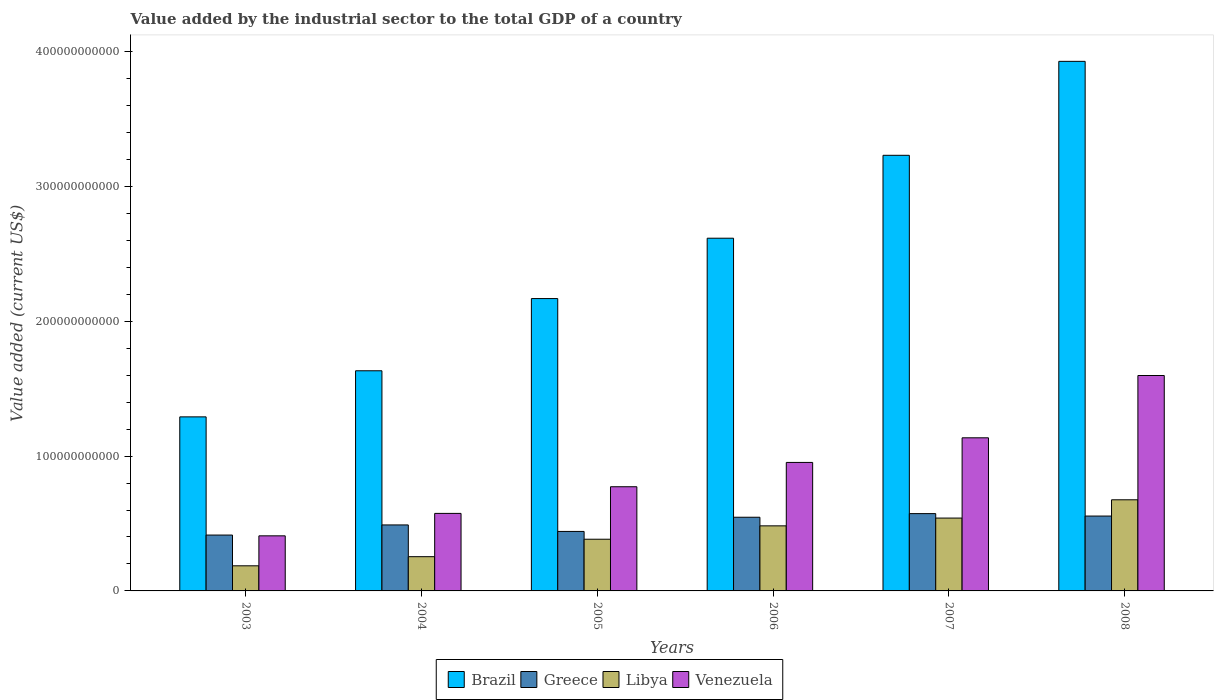How many different coloured bars are there?
Provide a succinct answer. 4. Are the number of bars per tick equal to the number of legend labels?
Offer a very short reply. Yes. Are the number of bars on each tick of the X-axis equal?
Ensure brevity in your answer.  Yes. How many bars are there on the 3rd tick from the left?
Make the answer very short. 4. How many bars are there on the 4th tick from the right?
Your answer should be compact. 4. What is the label of the 6th group of bars from the left?
Your response must be concise. 2008. In how many cases, is the number of bars for a given year not equal to the number of legend labels?
Provide a short and direct response. 0. What is the value added by the industrial sector to the total GDP in Libya in 2007?
Offer a terse response. 5.40e+1. Across all years, what is the maximum value added by the industrial sector to the total GDP in Venezuela?
Provide a short and direct response. 1.60e+11. Across all years, what is the minimum value added by the industrial sector to the total GDP in Libya?
Your response must be concise. 1.86e+1. What is the total value added by the industrial sector to the total GDP in Greece in the graph?
Keep it short and to the point. 3.02e+11. What is the difference between the value added by the industrial sector to the total GDP in Venezuela in 2004 and that in 2005?
Keep it short and to the point. -1.98e+1. What is the difference between the value added by the industrial sector to the total GDP in Brazil in 2005 and the value added by the industrial sector to the total GDP in Libya in 2004?
Keep it short and to the point. 1.91e+11. What is the average value added by the industrial sector to the total GDP in Libya per year?
Keep it short and to the point. 4.20e+1. In the year 2003, what is the difference between the value added by the industrial sector to the total GDP in Greece and value added by the industrial sector to the total GDP in Libya?
Your response must be concise. 2.28e+1. In how many years, is the value added by the industrial sector to the total GDP in Greece greater than 160000000000 US$?
Your answer should be compact. 0. What is the ratio of the value added by the industrial sector to the total GDP in Venezuela in 2003 to that in 2006?
Provide a succinct answer. 0.43. Is the difference between the value added by the industrial sector to the total GDP in Greece in 2003 and 2008 greater than the difference between the value added by the industrial sector to the total GDP in Libya in 2003 and 2008?
Your response must be concise. Yes. What is the difference between the highest and the second highest value added by the industrial sector to the total GDP in Libya?
Give a very brief answer. 1.35e+1. What is the difference between the highest and the lowest value added by the industrial sector to the total GDP in Brazil?
Your response must be concise. 2.64e+11. Is it the case that in every year, the sum of the value added by the industrial sector to the total GDP in Libya and value added by the industrial sector to the total GDP in Venezuela is greater than the sum of value added by the industrial sector to the total GDP in Greece and value added by the industrial sector to the total GDP in Brazil?
Your answer should be very brief. No. What does the 4th bar from the left in 2005 represents?
Provide a short and direct response. Venezuela. What does the 4th bar from the right in 2006 represents?
Your answer should be very brief. Brazil. Is it the case that in every year, the sum of the value added by the industrial sector to the total GDP in Libya and value added by the industrial sector to the total GDP in Greece is greater than the value added by the industrial sector to the total GDP in Brazil?
Offer a terse response. No. How many bars are there?
Provide a short and direct response. 24. Are all the bars in the graph horizontal?
Your answer should be very brief. No. What is the difference between two consecutive major ticks on the Y-axis?
Offer a terse response. 1.00e+11. Are the values on the major ticks of Y-axis written in scientific E-notation?
Keep it short and to the point. No. Does the graph contain any zero values?
Provide a short and direct response. No. Where does the legend appear in the graph?
Offer a terse response. Bottom center. What is the title of the graph?
Offer a very short reply. Value added by the industrial sector to the total GDP of a country. Does "Solomon Islands" appear as one of the legend labels in the graph?
Provide a succinct answer. No. What is the label or title of the X-axis?
Keep it short and to the point. Years. What is the label or title of the Y-axis?
Give a very brief answer. Value added (current US$). What is the Value added (current US$) of Brazil in 2003?
Give a very brief answer. 1.29e+11. What is the Value added (current US$) in Greece in 2003?
Provide a short and direct response. 4.14e+1. What is the Value added (current US$) of Libya in 2003?
Give a very brief answer. 1.86e+1. What is the Value added (current US$) of Venezuela in 2003?
Offer a terse response. 4.08e+1. What is the Value added (current US$) in Brazil in 2004?
Your answer should be compact. 1.63e+11. What is the Value added (current US$) in Greece in 2004?
Provide a short and direct response. 4.89e+1. What is the Value added (current US$) of Libya in 2004?
Offer a very short reply. 2.54e+1. What is the Value added (current US$) in Venezuela in 2004?
Give a very brief answer. 5.75e+1. What is the Value added (current US$) of Brazil in 2005?
Offer a terse response. 2.17e+11. What is the Value added (current US$) in Greece in 2005?
Your response must be concise. 4.41e+1. What is the Value added (current US$) in Libya in 2005?
Provide a short and direct response. 3.83e+1. What is the Value added (current US$) of Venezuela in 2005?
Provide a short and direct response. 7.73e+1. What is the Value added (current US$) in Brazil in 2006?
Your response must be concise. 2.62e+11. What is the Value added (current US$) of Greece in 2006?
Provide a succinct answer. 5.46e+1. What is the Value added (current US$) of Libya in 2006?
Keep it short and to the point. 4.83e+1. What is the Value added (current US$) of Venezuela in 2006?
Make the answer very short. 9.53e+1. What is the Value added (current US$) in Brazil in 2007?
Provide a succinct answer. 3.23e+11. What is the Value added (current US$) in Greece in 2007?
Your response must be concise. 5.73e+1. What is the Value added (current US$) in Libya in 2007?
Offer a terse response. 5.40e+1. What is the Value added (current US$) of Venezuela in 2007?
Give a very brief answer. 1.14e+11. What is the Value added (current US$) in Brazil in 2008?
Keep it short and to the point. 3.93e+11. What is the Value added (current US$) of Greece in 2008?
Your answer should be very brief. 5.55e+1. What is the Value added (current US$) of Libya in 2008?
Provide a short and direct response. 6.76e+1. What is the Value added (current US$) of Venezuela in 2008?
Your answer should be very brief. 1.60e+11. Across all years, what is the maximum Value added (current US$) of Brazil?
Your response must be concise. 3.93e+11. Across all years, what is the maximum Value added (current US$) in Greece?
Make the answer very short. 5.73e+1. Across all years, what is the maximum Value added (current US$) of Libya?
Your answer should be compact. 6.76e+1. Across all years, what is the maximum Value added (current US$) of Venezuela?
Make the answer very short. 1.60e+11. Across all years, what is the minimum Value added (current US$) of Brazil?
Provide a short and direct response. 1.29e+11. Across all years, what is the minimum Value added (current US$) in Greece?
Provide a succinct answer. 4.14e+1. Across all years, what is the minimum Value added (current US$) in Libya?
Your response must be concise. 1.86e+1. Across all years, what is the minimum Value added (current US$) of Venezuela?
Make the answer very short. 4.08e+1. What is the total Value added (current US$) in Brazil in the graph?
Your answer should be compact. 1.49e+12. What is the total Value added (current US$) of Greece in the graph?
Ensure brevity in your answer.  3.02e+11. What is the total Value added (current US$) in Libya in the graph?
Offer a very short reply. 2.52e+11. What is the total Value added (current US$) in Venezuela in the graph?
Offer a terse response. 5.44e+11. What is the difference between the Value added (current US$) of Brazil in 2003 and that in 2004?
Your answer should be compact. -3.42e+1. What is the difference between the Value added (current US$) in Greece in 2003 and that in 2004?
Offer a very short reply. -7.50e+09. What is the difference between the Value added (current US$) in Libya in 2003 and that in 2004?
Offer a very short reply. -6.77e+09. What is the difference between the Value added (current US$) of Venezuela in 2003 and that in 2004?
Make the answer very short. -1.66e+1. What is the difference between the Value added (current US$) in Brazil in 2003 and that in 2005?
Provide a short and direct response. -8.77e+1. What is the difference between the Value added (current US$) in Greece in 2003 and that in 2005?
Offer a terse response. -2.69e+09. What is the difference between the Value added (current US$) in Libya in 2003 and that in 2005?
Make the answer very short. -1.97e+1. What is the difference between the Value added (current US$) of Venezuela in 2003 and that in 2005?
Offer a terse response. -3.64e+1. What is the difference between the Value added (current US$) of Brazil in 2003 and that in 2006?
Provide a short and direct response. -1.32e+11. What is the difference between the Value added (current US$) in Greece in 2003 and that in 2006?
Ensure brevity in your answer.  -1.32e+1. What is the difference between the Value added (current US$) in Libya in 2003 and that in 2006?
Provide a succinct answer. -2.96e+1. What is the difference between the Value added (current US$) in Venezuela in 2003 and that in 2006?
Offer a very short reply. -5.44e+1. What is the difference between the Value added (current US$) of Brazil in 2003 and that in 2007?
Provide a succinct answer. -1.94e+11. What is the difference between the Value added (current US$) in Greece in 2003 and that in 2007?
Make the answer very short. -1.59e+1. What is the difference between the Value added (current US$) in Libya in 2003 and that in 2007?
Give a very brief answer. -3.54e+1. What is the difference between the Value added (current US$) of Venezuela in 2003 and that in 2007?
Your answer should be very brief. -7.27e+1. What is the difference between the Value added (current US$) in Brazil in 2003 and that in 2008?
Give a very brief answer. -2.64e+11. What is the difference between the Value added (current US$) in Greece in 2003 and that in 2008?
Ensure brevity in your answer.  -1.41e+1. What is the difference between the Value added (current US$) of Libya in 2003 and that in 2008?
Offer a terse response. -4.89e+1. What is the difference between the Value added (current US$) of Venezuela in 2003 and that in 2008?
Keep it short and to the point. -1.19e+11. What is the difference between the Value added (current US$) in Brazil in 2004 and that in 2005?
Provide a succinct answer. -5.35e+1. What is the difference between the Value added (current US$) of Greece in 2004 and that in 2005?
Provide a short and direct response. 4.82e+09. What is the difference between the Value added (current US$) of Libya in 2004 and that in 2005?
Your answer should be very brief. -1.29e+1. What is the difference between the Value added (current US$) of Venezuela in 2004 and that in 2005?
Your answer should be compact. -1.98e+1. What is the difference between the Value added (current US$) of Brazil in 2004 and that in 2006?
Offer a terse response. -9.83e+1. What is the difference between the Value added (current US$) of Greece in 2004 and that in 2006?
Your answer should be very brief. -5.70e+09. What is the difference between the Value added (current US$) in Libya in 2004 and that in 2006?
Give a very brief answer. -2.29e+1. What is the difference between the Value added (current US$) in Venezuela in 2004 and that in 2006?
Offer a very short reply. -3.78e+1. What is the difference between the Value added (current US$) of Brazil in 2004 and that in 2007?
Provide a short and direct response. -1.60e+11. What is the difference between the Value added (current US$) in Greece in 2004 and that in 2007?
Keep it short and to the point. -8.39e+09. What is the difference between the Value added (current US$) of Libya in 2004 and that in 2007?
Your answer should be compact. -2.86e+1. What is the difference between the Value added (current US$) of Venezuela in 2004 and that in 2007?
Provide a succinct answer. -5.61e+1. What is the difference between the Value added (current US$) in Brazil in 2004 and that in 2008?
Give a very brief answer. -2.29e+11. What is the difference between the Value added (current US$) of Greece in 2004 and that in 2008?
Your answer should be compact. -6.58e+09. What is the difference between the Value added (current US$) in Libya in 2004 and that in 2008?
Offer a very short reply. -4.22e+1. What is the difference between the Value added (current US$) of Venezuela in 2004 and that in 2008?
Offer a terse response. -1.02e+11. What is the difference between the Value added (current US$) in Brazil in 2005 and that in 2006?
Make the answer very short. -4.48e+1. What is the difference between the Value added (current US$) in Greece in 2005 and that in 2006?
Offer a very short reply. -1.05e+1. What is the difference between the Value added (current US$) of Libya in 2005 and that in 2006?
Keep it short and to the point. -9.93e+09. What is the difference between the Value added (current US$) in Venezuela in 2005 and that in 2006?
Ensure brevity in your answer.  -1.80e+1. What is the difference between the Value added (current US$) in Brazil in 2005 and that in 2007?
Give a very brief answer. -1.06e+11. What is the difference between the Value added (current US$) in Greece in 2005 and that in 2007?
Your answer should be very brief. -1.32e+1. What is the difference between the Value added (current US$) in Libya in 2005 and that in 2007?
Your answer should be very brief. -1.57e+1. What is the difference between the Value added (current US$) in Venezuela in 2005 and that in 2007?
Your answer should be compact. -3.63e+1. What is the difference between the Value added (current US$) in Brazil in 2005 and that in 2008?
Your response must be concise. -1.76e+11. What is the difference between the Value added (current US$) in Greece in 2005 and that in 2008?
Make the answer very short. -1.14e+1. What is the difference between the Value added (current US$) of Libya in 2005 and that in 2008?
Give a very brief answer. -2.92e+1. What is the difference between the Value added (current US$) in Venezuela in 2005 and that in 2008?
Make the answer very short. -8.25e+1. What is the difference between the Value added (current US$) in Brazil in 2006 and that in 2007?
Your answer should be compact. -6.15e+1. What is the difference between the Value added (current US$) in Greece in 2006 and that in 2007?
Give a very brief answer. -2.70e+09. What is the difference between the Value added (current US$) of Libya in 2006 and that in 2007?
Offer a terse response. -5.77e+09. What is the difference between the Value added (current US$) in Venezuela in 2006 and that in 2007?
Ensure brevity in your answer.  -1.83e+1. What is the difference between the Value added (current US$) in Brazil in 2006 and that in 2008?
Keep it short and to the point. -1.31e+11. What is the difference between the Value added (current US$) in Greece in 2006 and that in 2008?
Your response must be concise. -8.79e+08. What is the difference between the Value added (current US$) in Libya in 2006 and that in 2008?
Provide a short and direct response. -1.93e+1. What is the difference between the Value added (current US$) in Venezuela in 2006 and that in 2008?
Offer a very short reply. -6.45e+1. What is the difference between the Value added (current US$) of Brazil in 2007 and that in 2008?
Offer a terse response. -6.97e+1. What is the difference between the Value added (current US$) of Greece in 2007 and that in 2008?
Ensure brevity in your answer.  1.82e+09. What is the difference between the Value added (current US$) of Libya in 2007 and that in 2008?
Make the answer very short. -1.35e+1. What is the difference between the Value added (current US$) of Venezuela in 2007 and that in 2008?
Make the answer very short. -4.62e+1. What is the difference between the Value added (current US$) in Brazil in 2003 and the Value added (current US$) in Greece in 2004?
Provide a short and direct response. 8.01e+1. What is the difference between the Value added (current US$) in Brazil in 2003 and the Value added (current US$) in Libya in 2004?
Make the answer very short. 1.04e+11. What is the difference between the Value added (current US$) of Brazil in 2003 and the Value added (current US$) of Venezuela in 2004?
Offer a terse response. 7.16e+1. What is the difference between the Value added (current US$) of Greece in 2003 and the Value added (current US$) of Libya in 2004?
Your response must be concise. 1.60e+1. What is the difference between the Value added (current US$) of Greece in 2003 and the Value added (current US$) of Venezuela in 2004?
Give a very brief answer. -1.60e+1. What is the difference between the Value added (current US$) in Libya in 2003 and the Value added (current US$) in Venezuela in 2004?
Offer a terse response. -3.89e+1. What is the difference between the Value added (current US$) in Brazil in 2003 and the Value added (current US$) in Greece in 2005?
Make the answer very short. 8.49e+1. What is the difference between the Value added (current US$) of Brazil in 2003 and the Value added (current US$) of Libya in 2005?
Offer a very short reply. 9.07e+1. What is the difference between the Value added (current US$) of Brazil in 2003 and the Value added (current US$) of Venezuela in 2005?
Your answer should be very brief. 5.18e+1. What is the difference between the Value added (current US$) of Greece in 2003 and the Value added (current US$) of Libya in 2005?
Keep it short and to the point. 3.10e+09. What is the difference between the Value added (current US$) in Greece in 2003 and the Value added (current US$) in Venezuela in 2005?
Your answer should be very brief. -3.58e+1. What is the difference between the Value added (current US$) of Libya in 2003 and the Value added (current US$) of Venezuela in 2005?
Your answer should be compact. -5.86e+1. What is the difference between the Value added (current US$) in Brazil in 2003 and the Value added (current US$) in Greece in 2006?
Your answer should be compact. 7.44e+1. What is the difference between the Value added (current US$) of Brazil in 2003 and the Value added (current US$) of Libya in 2006?
Make the answer very short. 8.08e+1. What is the difference between the Value added (current US$) in Brazil in 2003 and the Value added (current US$) in Venezuela in 2006?
Provide a short and direct response. 3.38e+1. What is the difference between the Value added (current US$) in Greece in 2003 and the Value added (current US$) in Libya in 2006?
Offer a terse response. -6.83e+09. What is the difference between the Value added (current US$) of Greece in 2003 and the Value added (current US$) of Venezuela in 2006?
Provide a succinct answer. -5.38e+1. What is the difference between the Value added (current US$) of Libya in 2003 and the Value added (current US$) of Venezuela in 2006?
Give a very brief answer. -7.67e+1. What is the difference between the Value added (current US$) in Brazil in 2003 and the Value added (current US$) in Greece in 2007?
Provide a succinct answer. 7.17e+1. What is the difference between the Value added (current US$) of Brazil in 2003 and the Value added (current US$) of Libya in 2007?
Provide a short and direct response. 7.50e+1. What is the difference between the Value added (current US$) in Brazil in 2003 and the Value added (current US$) in Venezuela in 2007?
Make the answer very short. 1.55e+1. What is the difference between the Value added (current US$) of Greece in 2003 and the Value added (current US$) of Libya in 2007?
Provide a short and direct response. -1.26e+1. What is the difference between the Value added (current US$) in Greece in 2003 and the Value added (current US$) in Venezuela in 2007?
Ensure brevity in your answer.  -7.21e+1. What is the difference between the Value added (current US$) of Libya in 2003 and the Value added (current US$) of Venezuela in 2007?
Your answer should be very brief. -9.49e+1. What is the difference between the Value added (current US$) in Brazil in 2003 and the Value added (current US$) in Greece in 2008?
Offer a very short reply. 7.35e+1. What is the difference between the Value added (current US$) of Brazil in 2003 and the Value added (current US$) of Libya in 2008?
Offer a terse response. 6.15e+1. What is the difference between the Value added (current US$) of Brazil in 2003 and the Value added (current US$) of Venezuela in 2008?
Offer a very short reply. -3.07e+1. What is the difference between the Value added (current US$) in Greece in 2003 and the Value added (current US$) in Libya in 2008?
Provide a succinct answer. -2.61e+1. What is the difference between the Value added (current US$) in Greece in 2003 and the Value added (current US$) in Venezuela in 2008?
Your answer should be compact. -1.18e+11. What is the difference between the Value added (current US$) of Libya in 2003 and the Value added (current US$) of Venezuela in 2008?
Ensure brevity in your answer.  -1.41e+11. What is the difference between the Value added (current US$) in Brazil in 2004 and the Value added (current US$) in Greece in 2005?
Provide a short and direct response. 1.19e+11. What is the difference between the Value added (current US$) in Brazil in 2004 and the Value added (current US$) in Libya in 2005?
Your answer should be compact. 1.25e+11. What is the difference between the Value added (current US$) of Brazil in 2004 and the Value added (current US$) of Venezuela in 2005?
Your answer should be very brief. 8.60e+1. What is the difference between the Value added (current US$) of Greece in 2004 and the Value added (current US$) of Libya in 2005?
Make the answer very short. 1.06e+1. What is the difference between the Value added (current US$) of Greece in 2004 and the Value added (current US$) of Venezuela in 2005?
Keep it short and to the point. -2.83e+1. What is the difference between the Value added (current US$) in Libya in 2004 and the Value added (current US$) in Venezuela in 2005?
Ensure brevity in your answer.  -5.19e+1. What is the difference between the Value added (current US$) in Brazil in 2004 and the Value added (current US$) in Greece in 2006?
Provide a short and direct response. 1.09e+11. What is the difference between the Value added (current US$) of Brazil in 2004 and the Value added (current US$) of Libya in 2006?
Ensure brevity in your answer.  1.15e+11. What is the difference between the Value added (current US$) in Brazil in 2004 and the Value added (current US$) in Venezuela in 2006?
Offer a very short reply. 6.80e+1. What is the difference between the Value added (current US$) of Greece in 2004 and the Value added (current US$) of Libya in 2006?
Your answer should be compact. 6.77e+08. What is the difference between the Value added (current US$) in Greece in 2004 and the Value added (current US$) in Venezuela in 2006?
Provide a short and direct response. -4.63e+1. What is the difference between the Value added (current US$) of Libya in 2004 and the Value added (current US$) of Venezuela in 2006?
Offer a very short reply. -6.99e+1. What is the difference between the Value added (current US$) of Brazil in 2004 and the Value added (current US$) of Greece in 2007?
Give a very brief answer. 1.06e+11. What is the difference between the Value added (current US$) of Brazil in 2004 and the Value added (current US$) of Libya in 2007?
Make the answer very short. 1.09e+11. What is the difference between the Value added (current US$) of Brazil in 2004 and the Value added (current US$) of Venezuela in 2007?
Provide a succinct answer. 4.97e+1. What is the difference between the Value added (current US$) in Greece in 2004 and the Value added (current US$) in Libya in 2007?
Your answer should be compact. -5.09e+09. What is the difference between the Value added (current US$) of Greece in 2004 and the Value added (current US$) of Venezuela in 2007?
Provide a short and direct response. -6.46e+1. What is the difference between the Value added (current US$) in Libya in 2004 and the Value added (current US$) in Venezuela in 2007?
Your answer should be compact. -8.81e+1. What is the difference between the Value added (current US$) in Brazil in 2004 and the Value added (current US$) in Greece in 2008?
Offer a terse response. 1.08e+11. What is the difference between the Value added (current US$) in Brazil in 2004 and the Value added (current US$) in Libya in 2008?
Give a very brief answer. 9.57e+1. What is the difference between the Value added (current US$) in Brazil in 2004 and the Value added (current US$) in Venezuela in 2008?
Make the answer very short. 3.50e+09. What is the difference between the Value added (current US$) in Greece in 2004 and the Value added (current US$) in Libya in 2008?
Provide a short and direct response. -1.86e+1. What is the difference between the Value added (current US$) in Greece in 2004 and the Value added (current US$) in Venezuela in 2008?
Provide a succinct answer. -1.11e+11. What is the difference between the Value added (current US$) of Libya in 2004 and the Value added (current US$) of Venezuela in 2008?
Provide a succinct answer. -1.34e+11. What is the difference between the Value added (current US$) of Brazil in 2005 and the Value added (current US$) of Greece in 2006?
Your answer should be very brief. 1.62e+11. What is the difference between the Value added (current US$) in Brazil in 2005 and the Value added (current US$) in Libya in 2006?
Provide a short and direct response. 1.69e+11. What is the difference between the Value added (current US$) of Brazil in 2005 and the Value added (current US$) of Venezuela in 2006?
Keep it short and to the point. 1.22e+11. What is the difference between the Value added (current US$) in Greece in 2005 and the Value added (current US$) in Libya in 2006?
Offer a terse response. -4.14e+09. What is the difference between the Value added (current US$) in Greece in 2005 and the Value added (current US$) in Venezuela in 2006?
Your response must be concise. -5.12e+1. What is the difference between the Value added (current US$) in Libya in 2005 and the Value added (current US$) in Venezuela in 2006?
Provide a succinct answer. -5.69e+1. What is the difference between the Value added (current US$) in Brazil in 2005 and the Value added (current US$) in Greece in 2007?
Keep it short and to the point. 1.59e+11. What is the difference between the Value added (current US$) of Brazil in 2005 and the Value added (current US$) of Libya in 2007?
Your answer should be compact. 1.63e+11. What is the difference between the Value added (current US$) in Brazil in 2005 and the Value added (current US$) in Venezuela in 2007?
Give a very brief answer. 1.03e+11. What is the difference between the Value added (current US$) in Greece in 2005 and the Value added (current US$) in Libya in 2007?
Ensure brevity in your answer.  -9.91e+09. What is the difference between the Value added (current US$) of Greece in 2005 and the Value added (current US$) of Venezuela in 2007?
Offer a very short reply. -6.94e+1. What is the difference between the Value added (current US$) in Libya in 2005 and the Value added (current US$) in Venezuela in 2007?
Offer a very short reply. -7.52e+1. What is the difference between the Value added (current US$) in Brazil in 2005 and the Value added (current US$) in Greece in 2008?
Your answer should be compact. 1.61e+11. What is the difference between the Value added (current US$) of Brazil in 2005 and the Value added (current US$) of Libya in 2008?
Ensure brevity in your answer.  1.49e+11. What is the difference between the Value added (current US$) in Brazil in 2005 and the Value added (current US$) in Venezuela in 2008?
Make the answer very short. 5.70e+1. What is the difference between the Value added (current US$) of Greece in 2005 and the Value added (current US$) of Libya in 2008?
Keep it short and to the point. -2.35e+1. What is the difference between the Value added (current US$) of Greece in 2005 and the Value added (current US$) of Venezuela in 2008?
Give a very brief answer. -1.16e+11. What is the difference between the Value added (current US$) of Libya in 2005 and the Value added (current US$) of Venezuela in 2008?
Ensure brevity in your answer.  -1.21e+11. What is the difference between the Value added (current US$) in Brazil in 2006 and the Value added (current US$) in Greece in 2007?
Provide a succinct answer. 2.04e+11. What is the difference between the Value added (current US$) in Brazil in 2006 and the Value added (current US$) in Libya in 2007?
Make the answer very short. 2.08e+11. What is the difference between the Value added (current US$) in Brazil in 2006 and the Value added (current US$) in Venezuela in 2007?
Provide a short and direct response. 1.48e+11. What is the difference between the Value added (current US$) of Greece in 2006 and the Value added (current US$) of Libya in 2007?
Ensure brevity in your answer.  6.04e+08. What is the difference between the Value added (current US$) of Greece in 2006 and the Value added (current US$) of Venezuela in 2007?
Your answer should be compact. -5.89e+1. What is the difference between the Value added (current US$) of Libya in 2006 and the Value added (current US$) of Venezuela in 2007?
Keep it short and to the point. -6.53e+1. What is the difference between the Value added (current US$) in Brazil in 2006 and the Value added (current US$) in Greece in 2008?
Ensure brevity in your answer.  2.06e+11. What is the difference between the Value added (current US$) in Brazil in 2006 and the Value added (current US$) in Libya in 2008?
Your answer should be very brief. 1.94e+11. What is the difference between the Value added (current US$) of Brazil in 2006 and the Value added (current US$) of Venezuela in 2008?
Your answer should be very brief. 1.02e+11. What is the difference between the Value added (current US$) of Greece in 2006 and the Value added (current US$) of Libya in 2008?
Your answer should be compact. -1.29e+1. What is the difference between the Value added (current US$) in Greece in 2006 and the Value added (current US$) in Venezuela in 2008?
Offer a very short reply. -1.05e+11. What is the difference between the Value added (current US$) in Libya in 2006 and the Value added (current US$) in Venezuela in 2008?
Provide a succinct answer. -1.11e+11. What is the difference between the Value added (current US$) of Brazil in 2007 and the Value added (current US$) of Greece in 2008?
Your response must be concise. 2.68e+11. What is the difference between the Value added (current US$) of Brazil in 2007 and the Value added (current US$) of Libya in 2008?
Ensure brevity in your answer.  2.55e+11. What is the difference between the Value added (current US$) of Brazil in 2007 and the Value added (current US$) of Venezuela in 2008?
Offer a very short reply. 1.63e+11. What is the difference between the Value added (current US$) of Greece in 2007 and the Value added (current US$) of Libya in 2008?
Keep it short and to the point. -1.02e+1. What is the difference between the Value added (current US$) in Greece in 2007 and the Value added (current US$) in Venezuela in 2008?
Provide a succinct answer. -1.02e+11. What is the difference between the Value added (current US$) of Libya in 2007 and the Value added (current US$) of Venezuela in 2008?
Keep it short and to the point. -1.06e+11. What is the average Value added (current US$) in Brazil per year?
Your response must be concise. 2.48e+11. What is the average Value added (current US$) of Greece per year?
Make the answer very short. 5.03e+1. What is the average Value added (current US$) in Libya per year?
Provide a short and direct response. 4.20e+1. What is the average Value added (current US$) of Venezuela per year?
Ensure brevity in your answer.  9.07e+1. In the year 2003, what is the difference between the Value added (current US$) in Brazil and Value added (current US$) in Greece?
Offer a very short reply. 8.76e+1. In the year 2003, what is the difference between the Value added (current US$) in Brazil and Value added (current US$) in Libya?
Keep it short and to the point. 1.10e+11. In the year 2003, what is the difference between the Value added (current US$) of Brazil and Value added (current US$) of Venezuela?
Your response must be concise. 8.82e+1. In the year 2003, what is the difference between the Value added (current US$) of Greece and Value added (current US$) of Libya?
Ensure brevity in your answer.  2.28e+1. In the year 2003, what is the difference between the Value added (current US$) in Greece and Value added (current US$) in Venezuela?
Offer a terse response. 5.87e+08. In the year 2003, what is the difference between the Value added (current US$) of Libya and Value added (current US$) of Venezuela?
Give a very brief answer. -2.22e+1. In the year 2004, what is the difference between the Value added (current US$) in Brazil and Value added (current US$) in Greece?
Ensure brevity in your answer.  1.14e+11. In the year 2004, what is the difference between the Value added (current US$) of Brazil and Value added (current US$) of Libya?
Keep it short and to the point. 1.38e+11. In the year 2004, what is the difference between the Value added (current US$) in Brazil and Value added (current US$) in Venezuela?
Give a very brief answer. 1.06e+11. In the year 2004, what is the difference between the Value added (current US$) of Greece and Value added (current US$) of Libya?
Make the answer very short. 2.35e+1. In the year 2004, what is the difference between the Value added (current US$) of Greece and Value added (current US$) of Venezuela?
Offer a terse response. -8.55e+09. In the year 2004, what is the difference between the Value added (current US$) of Libya and Value added (current US$) of Venezuela?
Your answer should be very brief. -3.21e+1. In the year 2005, what is the difference between the Value added (current US$) of Brazil and Value added (current US$) of Greece?
Provide a short and direct response. 1.73e+11. In the year 2005, what is the difference between the Value added (current US$) of Brazil and Value added (current US$) of Libya?
Offer a very short reply. 1.78e+11. In the year 2005, what is the difference between the Value added (current US$) of Brazil and Value added (current US$) of Venezuela?
Your answer should be compact. 1.40e+11. In the year 2005, what is the difference between the Value added (current US$) in Greece and Value added (current US$) in Libya?
Provide a short and direct response. 5.79e+09. In the year 2005, what is the difference between the Value added (current US$) in Greece and Value added (current US$) in Venezuela?
Make the answer very short. -3.31e+1. In the year 2005, what is the difference between the Value added (current US$) in Libya and Value added (current US$) in Venezuela?
Provide a succinct answer. -3.89e+1. In the year 2006, what is the difference between the Value added (current US$) in Brazil and Value added (current US$) in Greece?
Provide a succinct answer. 2.07e+11. In the year 2006, what is the difference between the Value added (current US$) of Brazil and Value added (current US$) of Libya?
Your response must be concise. 2.13e+11. In the year 2006, what is the difference between the Value added (current US$) in Brazil and Value added (current US$) in Venezuela?
Offer a very short reply. 1.66e+11. In the year 2006, what is the difference between the Value added (current US$) of Greece and Value added (current US$) of Libya?
Your answer should be compact. 6.37e+09. In the year 2006, what is the difference between the Value added (current US$) in Greece and Value added (current US$) in Venezuela?
Your answer should be very brief. -4.06e+1. In the year 2006, what is the difference between the Value added (current US$) in Libya and Value added (current US$) in Venezuela?
Your answer should be compact. -4.70e+1. In the year 2007, what is the difference between the Value added (current US$) of Brazil and Value added (current US$) of Greece?
Ensure brevity in your answer.  2.66e+11. In the year 2007, what is the difference between the Value added (current US$) of Brazil and Value added (current US$) of Libya?
Your answer should be very brief. 2.69e+11. In the year 2007, what is the difference between the Value added (current US$) of Brazil and Value added (current US$) of Venezuela?
Your response must be concise. 2.09e+11. In the year 2007, what is the difference between the Value added (current US$) in Greece and Value added (current US$) in Libya?
Keep it short and to the point. 3.30e+09. In the year 2007, what is the difference between the Value added (current US$) in Greece and Value added (current US$) in Venezuela?
Ensure brevity in your answer.  -5.62e+1. In the year 2007, what is the difference between the Value added (current US$) in Libya and Value added (current US$) in Venezuela?
Provide a short and direct response. -5.95e+1. In the year 2008, what is the difference between the Value added (current US$) of Brazil and Value added (current US$) of Greece?
Your response must be concise. 3.37e+11. In the year 2008, what is the difference between the Value added (current US$) in Brazil and Value added (current US$) in Libya?
Provide a short and direct response. 3.25e+11. In the year 2008, what is the difference between the Value added (current US$) of Brazil and Value added (current US$) of Venezuela?
Ensure brevity in your answer.  2.33e+11. In the year 2008, what is the difference between the Value added (current US$) in Greece and Value added (current US$) in Libya?
Provide a short and direct response. -1.21e+1. In the year 2008, what is the difference between the Value added (current US$) of Greece and Value added (current US$) of Venezuela?
Offer a terse response. -1.04e+11. In the year 2008, what is the difference between the Value added (current US$) in Libya and Value added (current US$) in Venezuela?
Ensure brevity in your answer.  -9.22e+1. What is the ratio of the Value added (current US$) of Brazil in 2003 to that in 2004?
Give a very brief answer. 0.79. What is the ratio of the Value added (current US$) in Greece in 2003 to that in 2004?
Your response must be concise. 0.85. What is the ratio of the Value added (current US$) in Libya in 2003 to that in 2004?
Provide a short and direct response. 0.73. What is the ratio of the Value added (current US$) in Venezuela in 2003 to that in 2004?
Make the answer very short. 0.71. What is the ratio of the Value added (current US$) in Brazil in 2003 to that in 2005?
Keep it short and to the point. 0.6. What is the ratio of the Value added (current US$) of Greece in 2003 to that in 2005?
Offer a very short reply. 0.94. What is the ratio of the Value added (current US$) in Libya in 2003 to that in 2005?
Offer a very short reply. 0.49. What is the ratio of the Value added (current US$) in Venezuela in 2003 to that in 2005?
Offer a terse response. 0.53. What is the ratio of the Value added (current US$) in Brazil in 2003 to that in 2006?
Provide a short and direct response. 0.49. What is the ratio of the Value added (current US$) of Greece in 2003 to that in 2006?
Keep it short and to the point. 0.76. What is the ratio of the Value added (current US$) in Libya in 2003 to that in 2006?
Give a very brief answer. 0.39. What is the ratio of the Value added (current US$) of Venezuela in 2003 to that in 2006?
Your answer should be compact. 0.43. What is the ratio of the Value added (current US$) of Brazil in 2003 to that in 2007?
Give a very brief answer. 0.4. What is the ratio of the Value added (current US$) of Greece in 2003 to that in 2007?
Your answer should be very brief. 0.72. What is the ratio of the Value added (current US$) of Libya in 2003 to that in 2007?
Your response must be concise. 0.34. What is the ratio of the Value added (current US$) of Venezuela in 2003 to that in 2007?
Your answer should be compact. 0.36. What is the ratio of the Value added (current US$) in Brazil in 2003 to that in 2008?
Offer a very short reply. 0.33. What is the ratio of the Value added (current US$) of Greece in 2003 to that in 2008?
Keep it short and to the point. 0.75. What is the ratio of the Value added (current US$) in Libya in 2003 to that in 2008?
Keep it short and to the point. 0.28. What is the ratio of the Value added (current US$) in Venezuela in 2003 to that in 2008?
Offer a very short reply. 0.26. What is the ratio of the Value added (current US$) in Brazil in 2004 to that in 2005?
Keep it short and to the point. 0.75. What is the ratio of the Value added (current US$) in Greece in 2004 to that in 2005?
Your answer should be compact. 1.11. What is the ratio of the Value added (current US$) of Libya in 2004 to that in 2005?
Keep it short and to the point. 0.66. What is the ratio of the Value added (current US$) of Venezuela in 2004 to that in 2005?
Give a very brief answer. 0.74. What is the ratio of the Value added (current US$) of Brazil in 2004 to that in 2006?
Make the answer very short. 0.62. What is the ratio of the Value added (current US$) of Greece in 2004 to that in 2006?
Ensure brevity in your answer.  0.9. What is the ratio of the Value added (current US$) of Libya in 2004 to that in 2006?
Offer a very short reply. 0.53. What is the ratio of the Value added (current US$) of Venezuela in 2004 to that in 2006?
Your answer should be very brief. 0.6. What is the ratio of the Value added (current US$) of Brazil in 2004 to that in 2007?
Offer a terse response. 0.51. What is the ratio of the Value added (current US$) of Greece in 2004 to that in 2007?
Provide a short and direct response. 0.85. What is the ratio of the Value added (current US$) of Libya in 2004 to that in 2007?
Offer a terse response. 0.47. What is the ratio of the Value added (current US$) in Venezuela in 2004 to that in 2007?
Provide a succinct answer. 0.51. What is the ratio of the Value added (current US$) in Brazil in 2004 to that in 2008?
Your response must be concise. 0.42. What is the ratio of the Value added (current US$) of Greece in 2004 to that in 2008?
Provide a succinct answer. 0.88. What is the ratio of the Value added (current US$) in Libya in 2004 to that in 2008?
Provide a short and direct response. 0.38. What is the ratio of the Value added (current US$) in Venezuela in 2004 to that in 2008?
Keep it short and to the point. 0.36. What is the ratio of the Value added (current US$) of Brazil in 2005 to that in 2006?
Make the answer very short. 0.83. What is the ratio of the Value added (current US$) of Greece in 2005 to that in 2006?
Your response must be concise. 0.81. What is the ratio of the Value added (current US$) in Libya in 2005 to that in 2006?
Offer a very short reply. 0.79. What is the ratio of the Value added (current US$) of Venezuela in 2005 to that in 2006?
Provide a succinct answer. 0.81. What is the ratio of the Value added (current US$) in Brazil in 2005 to that in 2007?
Your answer should be very brief. 0.67. What is the ratio of the Value added (current US$) in Greece in 2005 to that in 2007?
Keep it short and to the point. 0.77. What is the ratio of the Value added (current US$) in Libya in 2005 to that in 2007?
Your answer should be compact. 0.71. What is the ratio of the Value added (current US$) of Venezuela in 2005 to that in 2007?
Provide a short and direct response. 0.68. What is the ratio of the Value added (current US$) in Brazil in 2005 to that in 2008?
Provide a succinct answer. 0.55. What is the ratio of the Value added (current US$) of Greece in 2005 to that in 2008?
Keep it short and to the point. 0.79. What is the ratio of the Value added (current US$) of Libya in 2005 to that in 2008?
Your answer should be very brief. 0.57. What is the ratio of the Value added (current US$) in Venezuela in 2005 to that in 2008?
Provide a short and direct response. 0.48. What is the ratio of the Value added (current US$) of Brazil in 2006 to that in 2007?
Ensure brevity in your answer.  0.81. What is the ratio of the Value added (current US$) in Greece in 2006 to that in 2007?
Give a very brief answer. 0.95. What is the ratio of the Value added (current US$) of Libya in 2006 to that in 2007?
Give a very brief answer. 0.89. What is the ratio of the Value added (current US$) in Venezuela in 2006 to that in 2007?
Your response must be concise. 0.84. What is the ratio of the Value added (current US$) of Brazil in 2006 to that in 2008?
Your response must be concise. 0.67. What is the ratio of the Value added (current US$) in Greece in 2006 to that in 2008?
Offer a very short reply. 0.98. What is the ratio of the Value added (current US$) of Libya in 2006 to that in 2008?
Provide a short and direct response. 0.71. What is the ratio of the Value added (current US$) in Venezuela in 2006 to that in 2008?
Offer a terse response. 0.6. What is the ratio of the Value added (current US$) in Brazil in 2007 to that in 2008?
Your response must be concise. 0.82. What is the ratio of the Value added (current US$) in Greece in 2007 to that in 2008?
Ensure brevity in your answer.  1.03. What is the ratio of the Value added (current US$) of Libya in 2007 to that in 2008?
Keep it short and to the point. 0.8. What is the ratio of the Value added (current US$) of Venezuela in 2007 to that in 2008?
Provide a succinct answer. 0.71. What is the difference between the highest and the second highest Value added (current US$) in Brazil?
Provide a short and direct response. 6.97e+1. What is the difference between the highest and the second highest Value added (current US$) in Greece?
Provide a short and direct response. 1.82e+09. What is the difference between the highest and the second highest Value added (current US$) of Libya?
Ensure brevity in your answer.  1.35e+1. What is the difference between the highest and the second highest Value added (current US$) in Venezuela?
Keep it short and to the point. 4.62e+1. What is the difference between the highest and the lowest Value added (current US$) of Brazil?
Keep it short and to the point. 2.64e+11. What is the difference between the highest and the lowest Value added (current US$) in Greece?
Your answer should be compact. 1.59e+1. What is the difference between the highest and the lowest Value added (current US$) in Libya?
Give a very brief answer. 4.89e+1. What is the difference between the highest and the lowest Value added (current US$) in Venezuela?
Ensure brevity in your answer.  1.19e+11. 